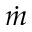<formula> <loc_0><loc_0><loc_500><loc_500>\dot { m }</formula> 